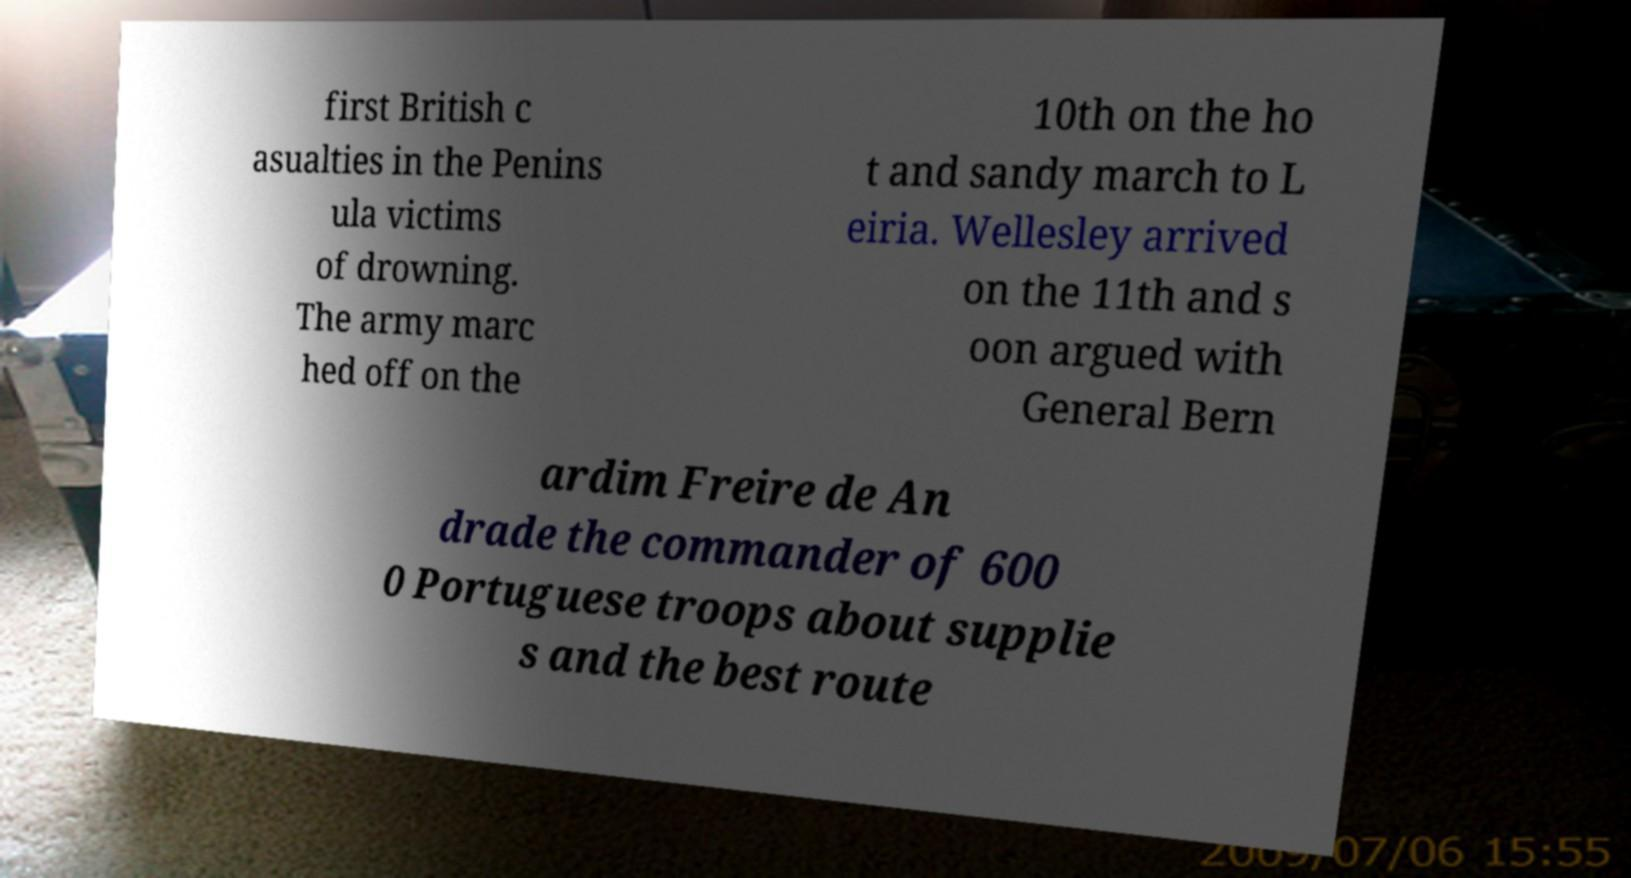Please identify and transcribe the text found in this image. first British c asualties in the Penins ula victims of drowning. The army marc hed off on the 10th on the ho t and sandy march to L eiria. Wellesley arrived on the 11th and s oon argued with General Bern ardim Freire de An drade the commander of 600 0 Portuguese troops about supplie s and the best route 